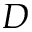Convert formula to latex. <formula><loc_0><loc_0><loc_500><loc_500>D</formula> 